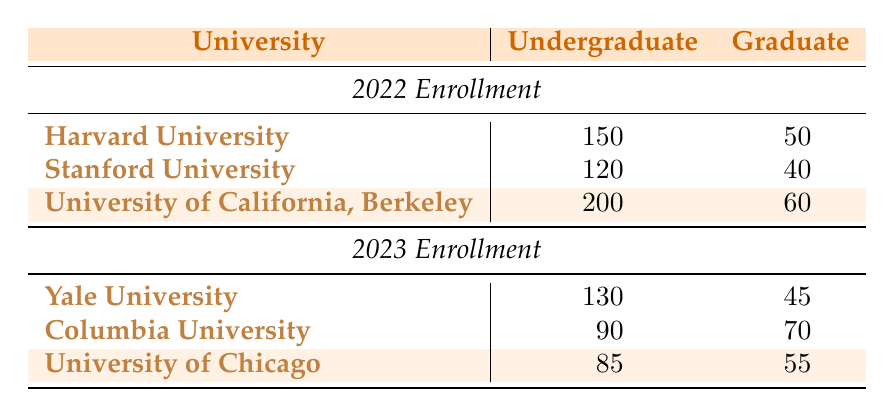What is the enrollment of Harvard University undergraduates in 2022? The table specifies that the enrollment for Harvard University undergraduates in 2022 is listed directly under the "Undergraduate" column for that year. The value is 150.
Answer: 150 Which university had the highest undergraduate enrollment in 2022? By inspecting the "Undergraduate" column for the year 2022, I can see that the University of California, Berkeley has the highest enrollment value of 200, compared to 150 for Harvard and 120 for Stanford.
Answer: University of California, Berkeley What is the total enrollment for graduate students at Stanford University in 2022? The enrollment for graduate students at Stanford University in 2022 is found directly in the "Graduate" column. The value listed is 40. Therefore, the total enrollment for this demographic is 40.
Answer: 40 What is the difference in undergraduate enrollment between University of California, Berkeley in 2022 and Yale University in 2023? The undergraduate enrollment at University of California, Berkeley in 2022 is 200, and at Yale University in 2023, it is 130. To find the difference, I subtract 130 from 200, which equals 70.
Answer: 70 Is the enrollment of graduate students at Columbia University greater than that at Yale University in 2023? Columbia University's graduate enrollment in 2023 is noted as 70, while Yale University's graduate enrollment during the same year is 45. Since 70 is greater than 45, the answer is yes.
Answer: Yes What is the average enrollment of undergraduate literature courses across all universities listed in 2022? First, I sum the undergraduate enrollments for all universities in 2022: 150 (Harvard) + 120 (Stanford) + 200 (UC Berkeley) = 470. There are three universities, so the average is 470 divided by 3, which is approximately 156.67.
Answer: 156.67 Which demographic had a lower total enrollment across all universities in 2022: undergraduate or graduate? Totaling the undergraduate enrollments: 150 (Harvard) + 120 (Stanford) + 200 (UC Berkeley) = 470. For graduate enrollments: 50 (Harvard) + 40 (Stanford) + 60 (UC Berkeley) = 150. Since 470 for undergraduates is greater than 150 for graduates, undergraduates had a higher total.
Answer: No What was the total enrollment for all demographics at the University of Chicago in 2023? For the University of Chicago in 2023, the undergraduate enrollment is 85, and the graduate enrollment is 55. To find the total enrollment, I add these two figures: 85 + 55, which equals 140.
Answer: 140 